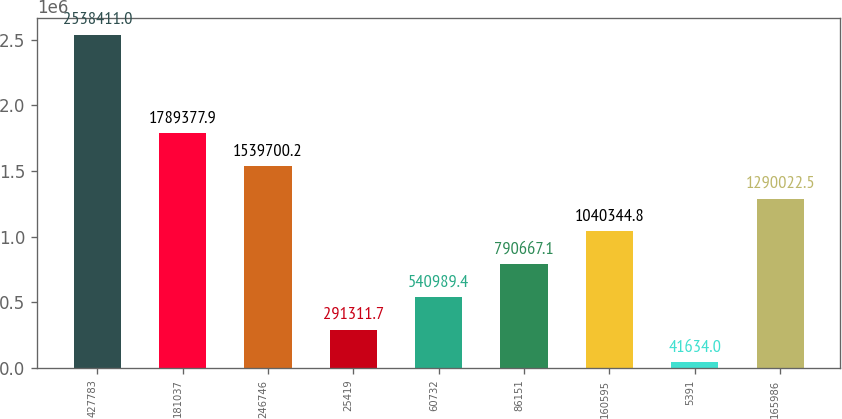<chart> <loc_0><loc_0><loc_500><loc_500><bar_chart><fcel>427783<fcel>181037<fcel>246746<fcel>25419<fcel>60732<fcel>86151<fcel>160595<fcel>5391<fcel>165986<nl><fcel>2.53841e+06<fcel>1.78938e+06<fcel>1.5397e+06<fcel>291312<fcel>540989<fcel>790667<fcel>1.04034e+06<fcel>41634<fcel>1.29002e+06<nl></chart> 